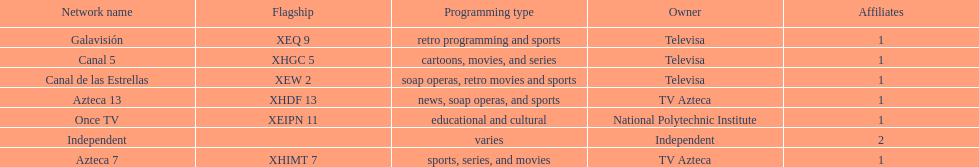What is the total number of affiliates among all the networks? 8. 